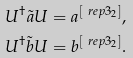Convert formula to latex. <formula><loc_0><loc_0><loc_500><loc_500>U ^ { \dagger } \tilde { a } U & = a ^ { [ \ r e p { 3 _ { 2 } } ] } , \\ U ^ { \dagger } \tilde { b } U & = b ^ { [ \ r e p { 3 _ { 2 } } ] } .</formula> 